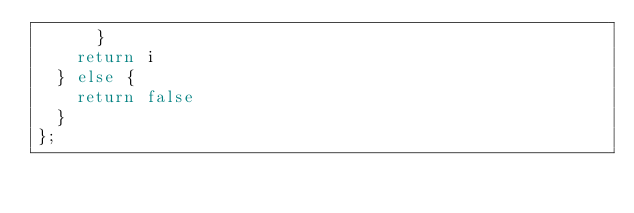<code> <loc_0><loc_0><loc_500><loc_500><_JavaScript_>      }
    return i
  } else {
    return false
  }
};
</code> 